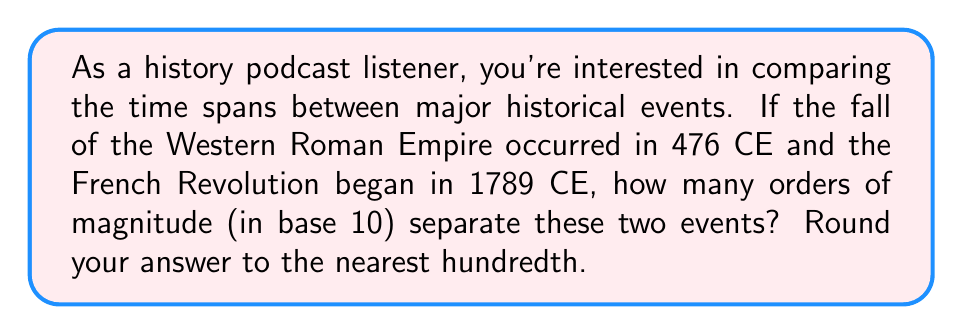Solve this math problem. To solve this problem, we'll use logarithms to calculate the orders of magnitude between these two events. Here's the step-by-step process:

1. Calculate the time difference between the events:
   1789 CE - 476 CE = 1313 years

2. To find the number of orders of magnitude, we need to calculate the base-10 logarithm of this time difference:
   $$ \text{Orders of magnitude} = \log_{10}(1313) $$

3. Using a calculator or logarithm table:
   $$ \log_{10}(1313) \approx 3.1183 $$

4. Rounding to the nearest hundredth:
   $$ 3.1183 \approx 3.12 $$

This result means that approximately 3.12 orders of magnitude (in base 10) separate the fall of the Western Roman Empire and the beginning of the French Revolution.
Answer: 3.12 